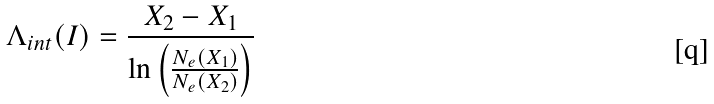Convert formula to latex. <formula><loc_0><loc_0><loc_500><loc_500>\Lambda _ { i n t } ( I ) = \frac { X _ { 2 } - X _ { 1 } } { \ln \left ( \frac { N _ { e } ( X _ { 1 } ) } { N _ { e } ( X _ { 2 } ) } \right ) }</formula> 